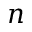<formula> <loc_0><loc_0><loc_500><loc_500>n</formula> 